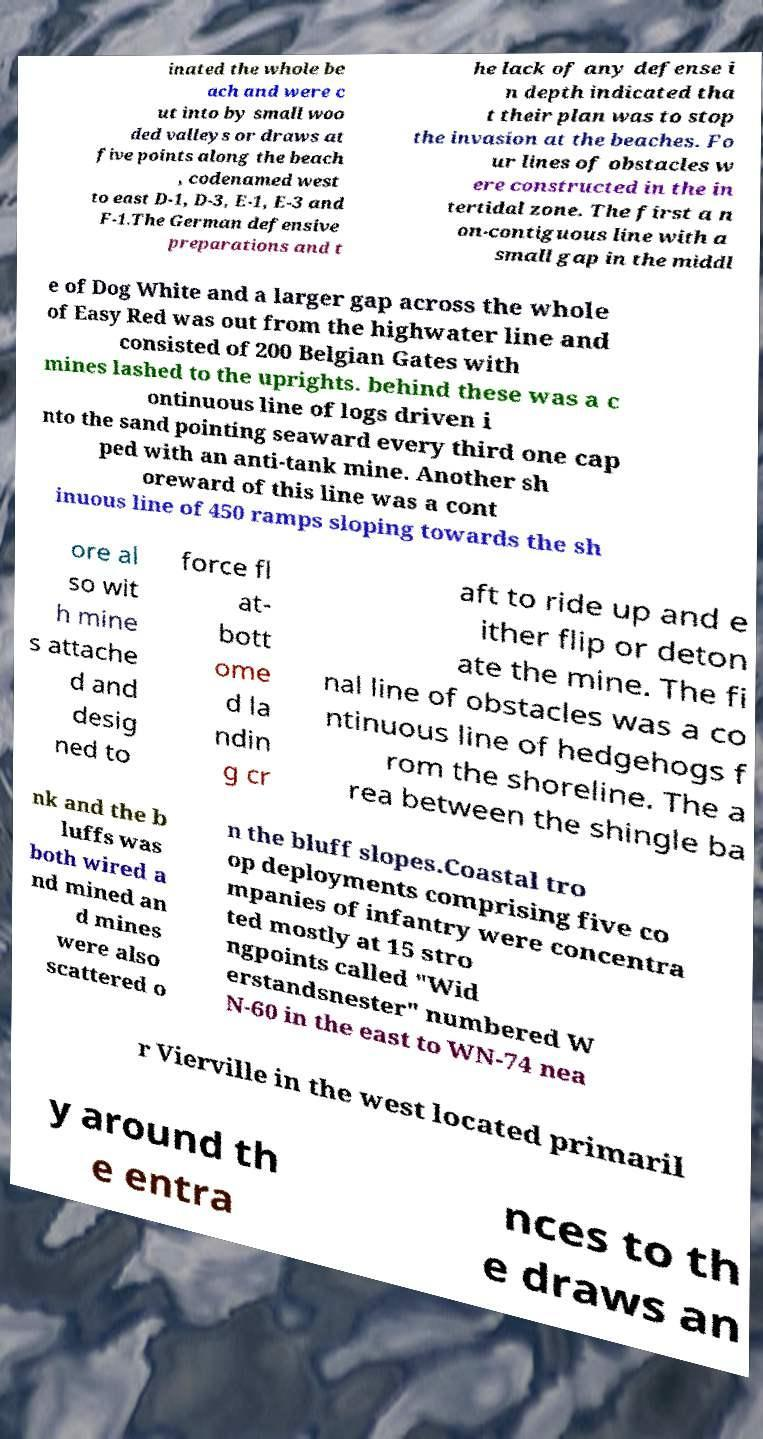Could you assist in decoding the text presented in this image and type it out clearly? inated the whole be ach and were c ut into by small woo ded valleys or draws at five points along the beach , codenamed west to east D-1, D-3, E-1, E-3 and F-1.The German defensive preparations and t he lack of any defense i n depth indicated tha t their plan was to stop the invasion at the beaches. Fo ur lines of obstacles w ere constructed in the in tertidal zone. The first a n on-contiguous line with a small gap in the middl e of Dog White and a larger gap across the whole of Easy Red was out from the highwater line and consisted of 200 Belgian Gates with mines lashed to the uprights. behind these was a c ontinuous line of logs driven i nto the sand pointing seaward every third one cap ped with an anti-tank mine. Another sh oreward of this line was a cont inuous line of 450 ramps sloping towards the sh ore al so wit h mine s attache d and desig ned to force fl at- bott ome d la ndin g cr aft to ride up and e ither flip or deton ate the mine. The fi nal line of obstacles was a co ntinuous line of hedgehogs f rom the shoreline. The a rea between the shingle ba nk and the b luffs was both wired a nd mined an d mines were also scattered o n the bluff slopes.Coastal tro op deployments comprising five co mpanies of infantry were concentra ted mostly at 15 stro ngpoints called "Wid erstandsnester" numbered W N-60 in the east to WN-74 nea r Vierville in the west located primaril y around th e entra nces to th e draws an 